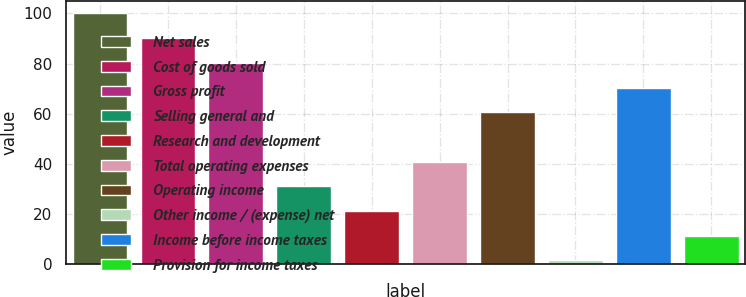Convert chart to OTSL. <chart><loc_0><loc_0><loc_500><loc_500><bar_chart><fcel>Net sales<fcel>Cost of goods sold<fcel>Gross profit<fcel>Selling general and<fcel>Research and development<fcel>Total operating expenses<fcel>Operating income<fcel>Other income / (expense) net<fcel>Income before income taxes<fcel>Provision for income taxes<nl><fcel>100<fcel>90.15<fcel>80.3<fcel>31.05<fcel>21.2<fcel>40.9<fcel>60.6<fcel>1.5<fcel>70.45<fcel>11.35<nl></chart> 